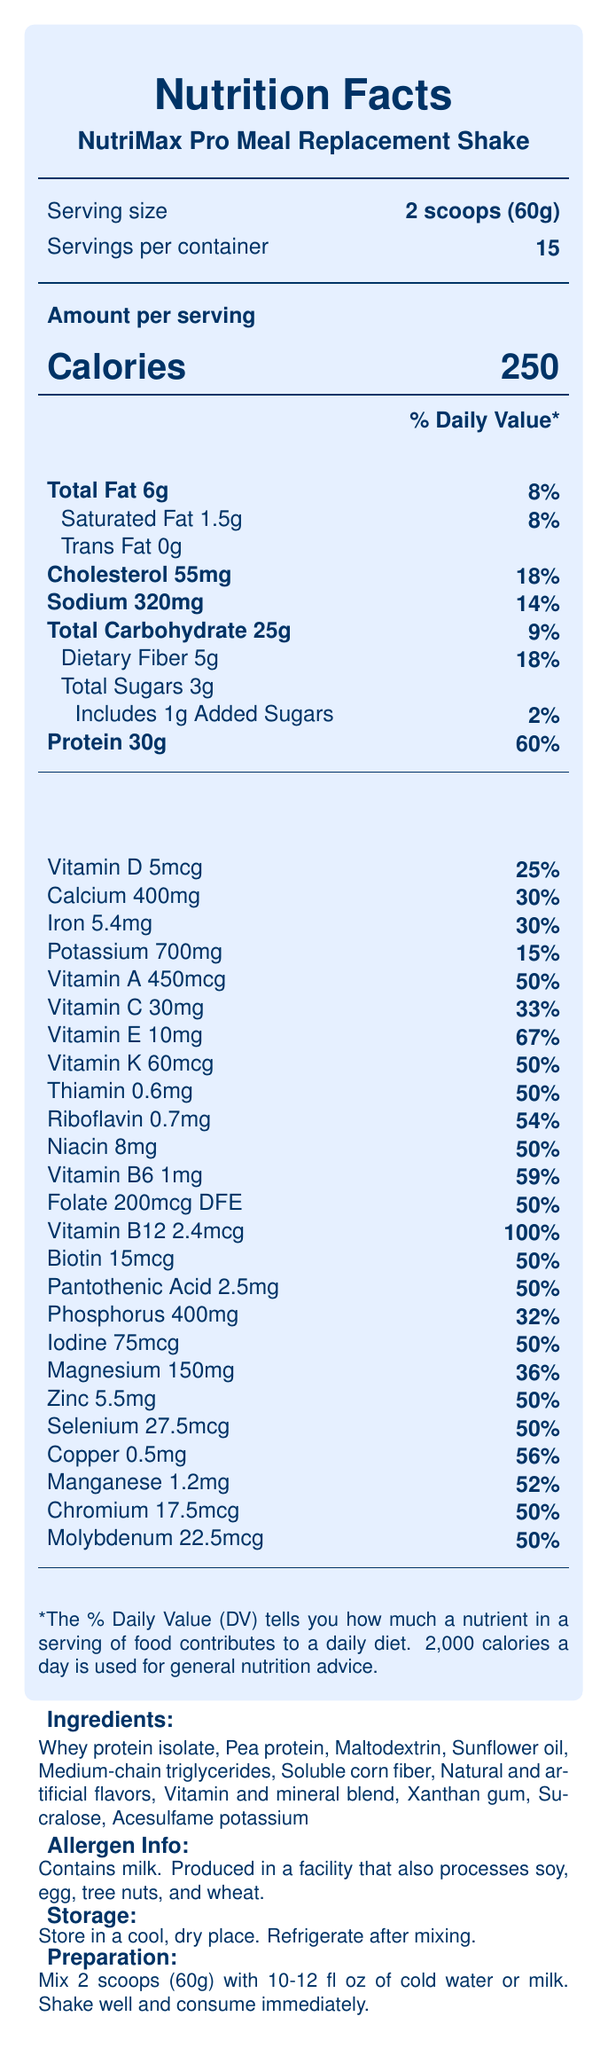what is the serving size? The serving size is clearly stated under the "Serving size" section.
Answer: 2 scoops (60g) how many calories are in one serving? The number of calories per serving is listed next to the word "Calories".
Answer: 250 how much protein does one serving provide? The amount of protein per serving is listed next to "Protein 30g" with a daily value of 60%.
Answer: 30g how much dietary fiber is in one serving? The amount of dietary fiber per serving is listed next to "Dietary Fiber 5g" with a daily value of 18%.
Answer: 5g what percentage of the daily value for Vitamin D does one serving provide? The percentage of the daily value for Vitamin D is listed next to "Vitamin D 5mcg" as 25%.
Answer: 25% what is the total fat content per serving? The total fat content per serving is listed next to "Total Fat 6g" with a daily value of 8%.
Answer: 6g what are the two main protein sources listed in the ingredients? The two main protein sources are the first two ingredients listed in the ingredients section.
Answer: Whey protein isolate and Pea protein which vitamin is present at the highest daily value percentage? A. Vitamin B6 B. Vitamin A C. Vitamin B12 D. Vitamin C Vitamin B12 is present at 100% of the daily value, which is the highest compared to the other listed options.
Answer: C what is the sodium content per serving? A. 320mg B. 400mg C. 250mg D. 500mg The sodium content per serving is listed as 320mg, with a daily value of 14%.
Answer: A how many servings are there per container? A. 10 B. 15 C. 20 D. 12 There are 15 servings per container, as stated under "Servings per container".
Answer: B does this product contain any trans fat? The label indicates "Trans Fat 0g".
Answer: No is this product suitable for someone with a soy allergy? The allergen info states that it is produced in a facility that also processes soy.
Answer: No provide a summary of the nutrition facts label for the NutriMax Pro Meal Replacement Shake. The label provides detailed nutritional information per serving, including macronutrients and micronutrients, allergen information, storage and preparation instructions, and is intended to support patients with malnutrition.
Answer: The NutriMax Pro Meal Replacement Shake provides 250 calories per serving (60g), with 6g of total fat, 30g of protein, and various vitamins and minerals. It is high in protein and dietary fiber, with moderate amounts of carbohydrates and fats. The product includes a comprehensive vitamin and mineral blend, making it suitable for patients with malnutrition. It contains milk and is produced in a facility that processes soy, egg, tree nuts, and wheat. The product comes with specific storage and preparation instructions. how many milligrams of potassium are in one serving? The label states that there are 700mg of potassium per serving, with a daily value of 15%.
Answer: 700mg how much added sugars does one serving include? The nutrition facts state that one serving includes 1g of added sugars, equating to 2% of the daily value.
Answer: 1g can this product be used as a sole source of nutrition? The clinical notes specify that it may be used as a sole source of nutrition or as a supplement to regular meals, as directed by a healthcare professional.
Answer: Yes what is the daily value percentage for magnesium in one serving? The daily value for magnesium listed is 36%, corresponding to the amount of 150mg.
Answer: 36% what is the mechanism of action of medium-chain triglycerides in malnutrition? The document does not provide details on the mechanism of action of medium-chain triglycerides in treating malnutrition.
Answer: Not enough information 